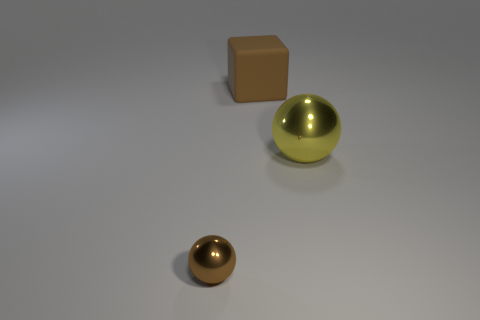How do the shapes of these objects compare? The objects exhibit fundamental geometric shapes. The large object in the center is a sphere, featuring a perfectly round shape in three dimensions. In contrast, the object on the left is a cube, with six equal square faces and edges of equal length. The smaller object in front appears to be a smaller sphere, resembling the larger sphere but at a reduced scale. 